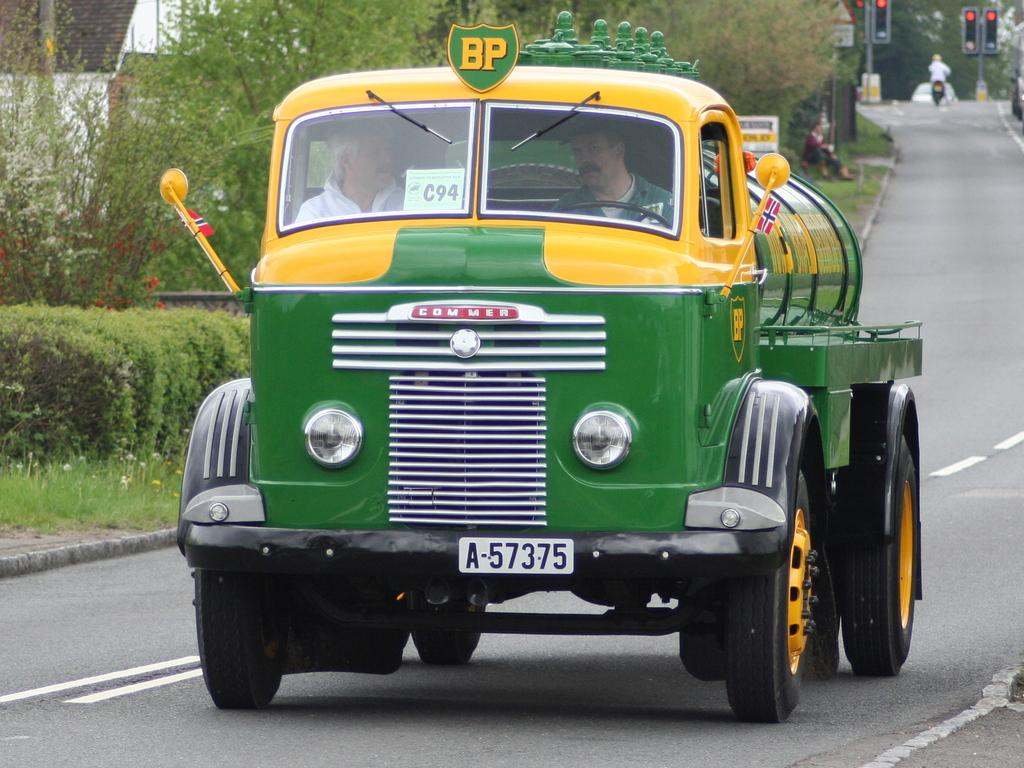<image>
Create a compact narrative representing the image presented. Green and yellow vehicle which says "COMMER" on it. 